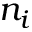<formula> <loc_0><loc_0><loc_500><loc_500>n _ { i }</formula> 